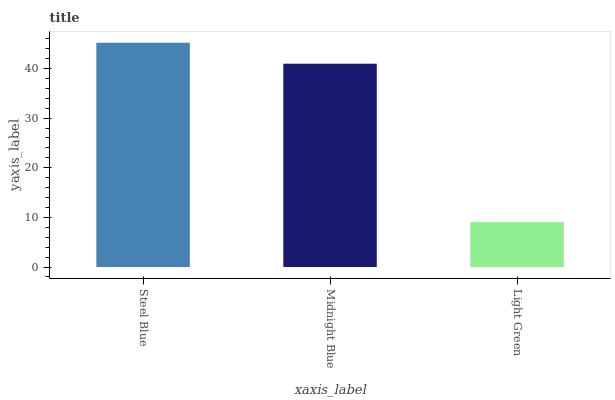Is Light Green the minimum?
Answer yes or no. Yes. Is Steel Blue the maximum?
Answer yes or no. Yes. Is Midnight Blue the minimum?
Answer yes or no. No. Is Midnight Blue the maximum?
Answer yes or no. No. Is Steel Blue greater than Midnight Blue?
Answer yes or no. Yes. Is Midnight Blue less than Steel Blue?
Answer yes or no. Yes. Is Midnight Blue greater than Steel Blue?
Answer yes or no. No. Is Steel Blue less than Midnight Blue?
Answer yes or no. No. Is Midnight Blue the high median?
Answer yes or no. Yes. Is Midnight Blue the low median?
Answer yes or no. Yes. Is Light Green the high median?
Answer yes or no. No. Is Steel Blue the low median?
Answer yes or no. No. 